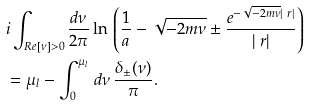Convert formula to latex. <formula><loc_0><loc_0><loc_500><loc_500>& i \int _ { R e [ \nu ] > 0 } \frac { d \nu } { 2 \pi } \ln \, \left ( \frac { 1 } { a } - \sqrt { - 2 m \nu } \pm \frac { e ^ { - \sqrt { - 2 m \nu } | \ r | } } { | \ r | } \right ) \\ & = \mu _ { l } - \int _ { 0 } ^ { \mu _ { l } } \, d \nu \, \frac { \delta _ { \pm } ( \nu ) } \pi .</formula> 